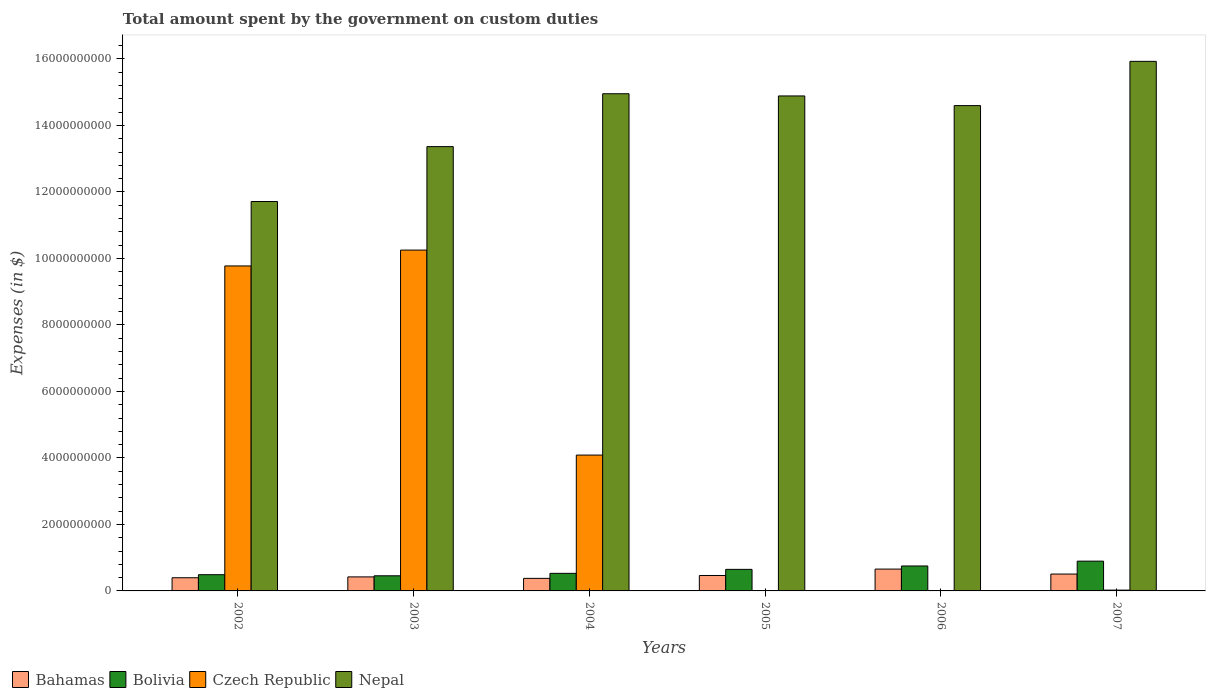How many different coloured bars are there?
Offer a terse response. 4. How many groups of bars are there?
Offer a very short reply. 6. Are the number of bars on each tick of the X-axis equal?
Make the answer very short. No. How many bars are there on the 5th tick from the left?
Give a very brief answer. 4. How many bars are there on the 5th tick from the right?
Give a very brief answer. 4. What is the label of the 5th group of bars from the left?
Make the answer very short. 2006. In how many cases, is the number of bars for a given year not equal to the number of legend labels?
Keep it short and to the point. 1. What is the amount spent on custom duties by the government in Czech Republic in 2007?
Offer a very short reply. 2.40e+07. Across all years, what is the maximum amount spent on custom duties by the government in Czech Republic?
Ensure brevity in your answer.  1.03e+1. Across all years, what is the minimum amount spent on custom duties by the government in Bolivia?
Provide a succinct answer. 4.55e+08. What is the total amount spent on custom duties by the government in Bahamas in the graph?
Provide a short and direct response. 2.82e+09. What is the difference between the amount spent on custom duties by the government in Bolivia in 2006 and that in 2007?
Keep it short and to the point. -1.45e+08. What is the difference between the amount spent on custom duties by the government in Bolivia in 2007 and the amount spent on custom duties by the government in Czech Republic in 2005?
Provide a short and direct response. 8.96e+08. What is the average amount spent on custom duties by the government in Bahamas per year?
Make the answer very short. 4.71e+08. In the year 2006, what is the difference between the amount spent on custom duties by the government in Nepal and amount spent on custom duties by the government in Bolivia?
Offer a very short reply. 1.38e+1. What is the ratio of the amount spent on custom duties by the government in Bahamas in 2004 to that in 2006?
Offer a terse response. 0.57. Is the amount spent on custom duties by the government in Bahamas in 2003 less than that in 2007?
Keep it short and to the point. Yes. Is the difference between the amount spent on custom duties by the government in Nepal in 2002 and 2003 greater than the difference between the amount spent on custom duties by the government in Bolivia in 2002 and 2003?
Your response must be concise. No. What is the difference between the highest and the second highest amount spent on custom duties by the government in Nepal?
Your answer should be very brief. 9.74e+08. What is the difference between the highest and the lowest amount spent on custom duties by the government in Bahamas?
Give a very brief answer. 2.79e+08. Is the sum of the amount spent on custom duties by the government in Nepal in 2006 and 2007 greater than the maximum amount spent on custom duties by the government in Bahamas across all years?
Provide a short and direct response. Yes. Is it the case that in every year, the sum of the amount spent on custom duties by the government in Bolivia and amount spent on custom duties by the government in Nepal is greater than the sum of amount spent on custom duties by the government in Czech Republic and amount spent on custom duties by the government in Bahamas?
Offer a terse response. Yes. How many years are there in the graph?
Provide a short and direct response. 6. What is the difference between two consecutive major ticks on the Y-axis?
Make the answer very short. 2.00e+09. Are the values on the major ticks of Y-axis written in scientific E-notation?
Keep it short and to the point. No. What is the title of the graph?
Your answer should be compact. Total amount spent by the government on custom duties. What is the label or title of the X-axis?
Offer a very short reply. Years. What is the label or title of the Y-axis?
Your answer should be very brief. Expenses (in $). What is the Expenses (in $) in Bahamas in 2002?
Make the answer very short. 3.96e+08. What is the Expenses (in $) in Bolivia in 2002?
Offer a very short reply. 4.88e+08. What is the Expenses (in $) of Czech Republic in 2002?
Offer a very short reply. 9.78e+09. What is the Expenses (in $) of Nepal in 2002?
Keep it short and to the point. 1.17e+1. What is the Expenses (in $) in Bahamas in 2003?
Give a very brief answer. 4.22e+08. What is the Expenses (in $) of Bolivia in 2003?
Your answer should be very brief. 4.55e+08. What is the Expenses (in $) in Czech Republic in 2003?
Make the answer very short. 1.03e+1. What is the Expenses (in $) of Nepal in 2003?
Give a very brief answer. 1.34e+1. What is the Expenses (in $) in Bahamas in 2004?
Provide a succinct answer. 3.77e+08. What is the Expenses (in $) of Bolivia in 2004?
Give a very brief answer. 5.28e+08. What is the Expenses (in $) of Czech Republic in 2004?
Your response must be concise. 4.09e+09. What is the Expenses (in $) in Nepal in 2004?
Offer a terse response. 1.50e+1. What is the Expenses (in $) in Bahamas in 2005?
Make the answer very short. 4.64e+08. What is the Expenses (in $) of Bolivia in 2005?
Give a very brief answer. 6.48e+08. What is the Expenses (in $) in Nepal in 2005?
Provide a short and direct response. 1.49e+1. What is the Expenses (in $) of Bahamas in 2006?
Provide a succinct answer. 6.57e+08. What is the Expenses (in $) of Bolivia in 2006?
Give a very brief answer. 7.50e+08. What is the Expenses (in $) in Czech Republic in 2006?
Keep it short and to the point. 6.00e+06. What is the Expenses (in $) in Nepal in 2006?
Your answer should be very brief. 1.46e+1. What is the Expenses (in $) in Bahamas in 2007?
Provide a succinct answer. 5.07e+08. What is the Expenses (in $) in Bolivia in 2007?
Provide a succinct answer. 8.96e+08. What is the Expenses (in $) of Czech Republic in 2007?
Keep it short and to the point. 2.40e+07. What is the Expenses (in $) in Nepal in 2007?
Provide a succinct answer. 1.59e+1. Across all years, what is the maximum Expenses (in $) of Bahamas?
Provide a short and direct response. 6.57e+08. Across all years, what is the maximum Expenses (in $) of Bolivia?
Offer a terse response. 8.96e+08. Across all years, what is the maximum Expenses (in $) of Czech Republic?
Your answer should be very brief. 1.03e+1. Across all years, what is the maximum Expenses (in $) in Nepal?
Make the answer very short. 1.59e+1. Across all years, what is the minimum Expenses (in $) in Bahamas?
Your response must be concise. 3.77e+08. Across all years, what is the minimum Expenses (in $) in Bolivia?
Keep it short and to the point. 4.55e+08. Across all years, what is the minimum Expenses (in $) of Nepal?
Make the answer very short. 1.17e+1. What is the total Expenses (in $) of Bahamas in the graph?
Offer a terse response. 2.82e+09. What is the total Expenses (in $) of Bolivia in the graph?
Offer a terse response. 3.77e+09. What is the total Expenses (in $) of Czech Republic in the graph?
Make the answer very short. 2.41e+1. What is the total Expenses (in $) in Nepal in the graph?
Your response must be concise. 8.54e+1. What is the difference between the Expenses (in $) in Bahamas in 2002 and that in 2003?
Give a very brief answer. -2.56e+07. What is the difference between the Expenses (in $) of Bolivia in 2002 and that in 2003?
Offer a very short reply. 3.30e+07. What is the difference between the Expenses (in $) of Czech Republic in 2002 and that in 2003?
Offer a very short reply. -4.77e+08. What is the difference between the Expenses (in $) in Nepal in 2002 and that in 2003?
Your answer should be compact. -1.65e+09. What is the difference between the Expenses (in $) of Bahamas in 2002 and that in 2004?
Ensure brevity in your answer.  1.87e+07. What is the difference between the Expenses (in $) in Bolivia in 2002 and that in 2004?
Ensure brevity in your answer.  -4.01e+07. What is the difference between the Expenses (in $) in Czech Republic in 2002 and that in 2004?
Offer a very short reply. 5.69e+09. What is the difference between the Expenses (in $) in Nepal in 2002 and that in 2004?
Offer a very short reply. -3.24e+09. What is the difference between the Expenses (in $) of Bahamas in 2002 and that in 2005?
Provide a short and direct response. -6.81e+07. What is the difference between the Expenses (in $) of Bolivia in 2002 and that in 2005?
Your response must be concise. -1.60e+08. What is the difference between the Expenses (in $) of Nepal in 2002 and that in 2005?
Offer a very short reply. -3.18e+09. What is the difference between the Expenses (in $) of Bahamas in 2002 and that in 2006?
Make the answer very short. -2.60e+08. What is the difference between the Expenses (in $) in Bolivia in 2002 and that in 2006?
Offer a very short reply. -2.62e+08. What is the difference between the Expenses (in $) in Czech Republic in 2002 and that in 2006?
Ensure brevity in your answer.  9.77e+09. What is the difference between the Expenses (in $) of Nepal in 2002 and that in 2006?
Your answer should be very brief. -2.88e+09. What is the difference between the Expenses (in $) in Bahamas in 2002 and that in 2007?
Ensure brevity in your answer.  -1.11e+08. What is the difference between the Expenses (in $) in Bolivia in 2002 and that in 2007?
Your answer should be compact. -4.07e+08. What is the difference between the Expenses (in $) of Czech Republic in 2002 and that in 2007?
Make the answer very short. 9.75e+09. What is the difference between the Expenses (in $) in Nepal in 2002 and that in 2007?
Offer a very short reply. -4.22e+09. What is the difference between the Expenses (in $) of Bahamas in 2003 and that in 2004?
Your response must be concise. 4.43e+07. What is the difference between the Expenses (in $) of Bolivia in 2003 and that in 2004?
Provide a succinct answer. -7.31e+07. What is the difference between the Expenses (in $) of Czech Republic in 2003 and that in 2004?
Provide a short and direct response. 6.17e+09. What is the difference between the Expenses (in $) of Nepal in 2003 and that in 2004?
Offer a terse response. -1.59e+09. What is the difference between the Expenses (in $) in Bahamas in 2003 and that in 2005?
Make the answer very short. -4.25e+07. What is the difference between the Expenses (in $) in Bolivia in 2003 and that in 2005?
Offer a terse response. -1.93e+08. What is the difference between the Expenses (in $) of Nepal in 2003 and that in 2005?
Keep it short and to the point. -1.52e+09. What is the difference between the Expenses (in $) in Bahamas in 2003 and that in 2006?
Your answer should be compact. -2.35e+08. What is the difference between the Expenses (in $) of Bolivia in 2003 and that in 2006?
Offer a very short reply. -2.95e+08. What is the difference between the Expenses (in $) in Czech Republic in 2003 and that in 2006?
Your answer should be compact. 1.02e+1. What is the difference between the Expenses (in $) of Nepal in 2003 and that in 2006?
Your answer should be very brief. -1.23e+09. What is the difference between the Expenses (in $) of Bahamas in 2003 and that in 2007?
Keep it short and to the point. -8.56e+07. What is the difference between the Expenses (in $) in Bolivia in 2003 and that in 2007?
Your answer should be compact. -4.40e+08. What is the difference between the Expenses (in $) in Czech Republic in 2003 and that in 2007?
Keep it short and to the point. 1.02e+1. What is the difference between the Expenses (in $) of Nepal in 2003 and that in 2007?
Offer a very short reply. -2.56e+09. What is the difference between the Expenses (in $) in Bahamas in 2004 and that in 2005?
Offer a terse response. -8.68e+07. What is the difference between the Expenses (in $) in Bolivia in 2004 and that in 2005?
Offer a very short reply. -1.20e+08. What is the difference between the Expenses (in $) of Nepal in 2004 and that in 2005?
Ensure brevity in your answer.  6.61e+07. What is the difference between the Expenses (in $) in Bahamas in 2004 and that in 2006?
Offer a very short reply. -2.79e+08. What is the difference between the Expenses (in $) of Bolivia in 2004 and that in 2006?
Provide a short and direct response. -2.22e+08. What is the difference between the Expenses (in $) in Czech Republic in 2004 and that in 2006?
Ensure brevity in your answer.  4.08e+09. What is the difference between the Expenses (in $) in Nepal in 2004 and that in 2006?
Provide a short and direct response. 3.57e+08. What is the difference between the Expenses (in $) of Bahamas in 2004 and that in 2007?
Your answer should be very brief. -1.30e+08. What is the difference between the Expenses (in $) in Bolivia in 2004 and that in 2007?
Ensure brevity in your answer.  -3.67e+08. What is the difference between the Expenses (in $) of Czech Republic in 2004 and that in 2007?
Make the answer very short. 4.06e+09. What is the difference between the Expenses (in $) in Nepal in 2004 and that in 2007?
Make the answer very short. -9.74e+08. What is the difference between the Expenses (in $) of Bahamas in 2005 and that in 2006?
Your response must be concise. -1.92e+08. What is the difference between the Expenses (in $) of Bolivia in 2005 and that in 2006?
Ensure brevity in your answer.  -1.02e+08. What is the difference between the Expenses (in $) in Nepal in 2005 and that in 2006?
Your response must be concise. 2.91e+08. What is the difference between the Expenses (in $) in Bahamas in 2005 and that in 2007?
Your answer should be compact. -4.31e+07. What is the difference between the Expenses (in $) in Bolivia in 2005 and that in 2007?
Your response must be concise. -2.47e+08. What is the difference between the Expenses (in $) of Nepal in 2005 and that in 2007?
Provide a short and direct response. -1.04e+09. What is the difference between the Expenses (in $) in Bahamas in 2006 and that in 2007?
Provide a short and direct response. 1.49e+08. What is the difference between the Expenses (in $) of Bolivia in 2006 and that in 2007?
Make the answer very short. -1.45e+08. What is the difference between the Expenses (in $) of Czech Republic in 2006 and that in 2007?
Your response must be concise. -1.80e+07. What is the difference between the Expenses (in $) of Nepal in 2006 and that in 2007?
Provide a succinct answer. -1.33e+09. What is the difference between the Expenses (in $) in Bahamas in 2002 and the Expenses (in $) in Bolivia in 2003?
Offer a terse response. -5.90e+07. What is the difference between the Expenses (in $) in Bahamas in 2002 and the Expenses (in $) in Czech Republic in 2003?
Offer a very short reply. -9.86e+09. What is the difference between the Expenses (in $) of Bahamas in 2002 and the Expenses (in $) of Nepal in 2003?
Make the answer very short. -1.30e+1. What is the difference between the Expenses (in $) of Bolivia in 2002 and the Expenses (in $) of Czech Republic in 2003?
Your answer should be compact. -9.76e+09. What is the difference between the Expenses (in $) in Bolivia in 2002 and the Expenses (in $) in Nepal in 2003?
Make the answer very short. -1.29e+1. What is the difference between the Expenses (in $) in Czech Republic in 2002 and the Expenses (in $) in Nepal in 2003?
Give a very brief answer. -3.59e+09. What is the difference between the Expenses (in $) of Bahamas in 2002 and the Expenses (in $) of Bolivia in 2004?
Offer a very short reply. -1.32e+08. What is the difference between the Expenses (in $) in Bahamas in 2002 and the Expenses (in $) in Czech Republic in 2004?
Make the answer very short. -3.69e+09. What is the difference between the Expenses (in $) in Bahamas in 2002 and the Expenses (in $) in Nepal in 2004?
Keep it short and to the point. -1.46e+1. What is the difference between the Expenses (in $) of Bolivia in 2002 and the Expenses (in $) of Czech Republic in 2004?
Provide a short and direct response. -3.60e+09. What is the difference between the Expenses (in $) in Bolivia in 2002 and the Expenses (in $) in Nepal in 2004?
Offer a very short reply. -1.45e+1. What is the difference between the Expenses (in $) of Czech Republic in 2002 and the Expenses (in $) of Nepal in 2004?
Keep it short and to the point. -5.18e+09. What is the difference between the Expenses (in $) in Bahamas in 2002 and the Expenses (in $) in Bolivia in 2005?
Ensure brevity in your answer.  -2.52e+08. What is the difference between the Expenses (in $) in Bahamas in 2002 and the Expenses (in $) in Nepal in 2005?
Give a very brief answer. -1.45e+1. What is the difference between the Expenses (in $) in Bolivia in 2002 and the Expenses (in $) in Nepal in 2005?
Provide a short and direct response. -1.44e+1. What is the difference between the Expenses (in $) of Czech Republic in 2002 and the Expenses (in $) of Nepal in 2005?
Ensure brevity in your answer.  -5.11e+09. What is the difference between the Expenses (in $) of Bahamas in 2002 and the Expenses (in $) of Bolivia in 2006?
Provide a short and direct response. -3.54e+08. What is the difference between the Expenses (in $) in Bahamas in 2002 and the Expenses (in $) in Czech Republic in 2006?
Provide a succinct answer. 3.90e+08. What is the difference between the Expenses (in $) of Bahamas in 2002 and the Expenses (in $) of Nepal in 2006?
Give a very brief answer. -1.42e+1. What is the difference between the Expenses (in $) of Bolivia in 2002 and the Expenses (in $) of Czech Republic in 2006?
Give a very brief answer. 4.82e+08. What is the difference between the Expenses (in $) in Bolivia in 2002 and the Expenses (in $) in Nepal in 2006?
Offer a terse response. -1.41e+1. What is the difference between the Expenses (in $) of Czech Republic in 2002 and the Expenses (in $) of Nepal in 2006?
Your response must be concise. -4.82e+09. What is the difference between the Expenses (in $) in Bahamas in 2002 and the Expenses (in $) in Bolivia in 2007?
Ensure brevity in your answer.  -4.99e+08. What is the difference between the Expenses (in $) in Bahamas in 2002 and the Expenses (in $) in Czech Republic in 2007?
Give a very brief answer. 3.72e+08. What is the difference between the Expenses (in $) of Bahamas in 2002 and the Expenses (in $) of Nepal in 2007?
Keep it short and to the point. -1.55e+1. What is the difference between the Expenses (in $) in Bolivia in 2002 and the Expenses (in $) in Czech Republic in 2007?
Make the answer very short. 4.64e+08. What is the difference between the Expenses (in $) in Bolivia in 2002 and the Expenses (in $) in Nepal in 2007?
Ensure brevity in your answer.  -1.54e+1. What is the difference between the Expenses (in $) in Czech Republic in 2002 and the Expenses (in $) in Nepal in 2007?
Your response must be concise. -6.15e+09. What is the difference between the Expenses (in $) in Bahamas in 2003 and the Expenses (in $) in Bolivia in 2004?
Your answer should be compact. -1.06e+08. What is the difference between the Expenses (in $) in Bahamas in 2003 and the Expenses (in $) in Czech Republic in 2004?
Your response must be concise. -3.66e+09. What is the difference between the Expenses (in $) in Bahamas in 2003 and the Expenses (in $) in Nepal in 2004?
Offer a terse response. -1.45e+1. What is the difference between the Expenses (in $) in Bolivia in 2003 and the Expenses (in $) in Czech Republic in 2004?
Offer a very short reply. -3.63e+09. What is the difference between the Expenses (in $) in Bolivia in 2003 and the Expenses (in $) in Nepal in 2004?
Provide a short and direct response. -1.45e+1. What is the difference between the Expenses (in $) in Czech Republic in 2003 and the Expenses (in $) in Nepal in 2004?
Your response must be concise. -4.70e+09. What is the difference between the Expenses (in $) in Bahamas in 2003 and the Expenses (in $) in Bolivia in 2005?
Your response must be concise. -2.27e+08. What is the difference between the Expenses (in $) of Bahamas in 2003 and the Expenses (in $) of Nepal in 2005?
Provide a short and direct response. -1.45e+1. What is the difference between the Expenses (in $) of Bolivia in 2003 and the Expenses (in $) of Nepal in 2005?
Your response must be concise. -1.44e+1. What is the difference between the Expenses (in $) in Czech Republic in 2003 and the Expenses (in $) in Nepal in 2005?
Your answer should be very brief. -4.64e+09. What is the difference between the Expenses (in $) of Bahamas in 2003 and the Expenses (in $) of Bolivia in 2006?
Offer a terse response. -3.29e+08. What is the difference between the Expenses (in $) of Bahamas in 2003 and the Expenses (in $) of Czech Republic in 2006?
Your answer should be very brief. 4.16e+08. What is the difference between the Expenses (in $) of Bahamas in 2003 and the Expenses (in $) of Nepal in 2006?
Provide a succinct answer. -1.42e+1. What is the difference between the Expenses (in $) of Bolivia in 2003 and the Expenses (in $) of Czech Republic in 2006?
Give a very brief answer. 4.49e+08. What is the difference between the Expenses (in $) of Bolivia in 2003 and the Expenses (in $) of Nepal in 2006?
Your answer should be compact. -1.41e+1. What is the difference between the Expenses (in $) of Czech Republic in 2003 and the Expenses (in $) of Nepal in 2006?
Keep it short and to the point. -4.35e+09. What is the difference between the Expenses (in $) of Bahamas in 2003 and the Expenses (in $) of Bolivia in 2007?
Your answer should be compact. -4.74e+08. What is the difference between the Expenses (in $) in Bahamas in 2003 and the Expenses (in $) in Czech Republic in 2007?
Give a very brief answer. 3.98e+08. What is the difference between the Expenses (in $) in Bahamas in 2003 and the Expenses (in $) in Nepal in 2007?
Offer a very short reply. -1.55e+1. What is the difference between the Expenses (in $) of Bolivia in 2003 and the Expenses (in $) of Czech Republic in 2007?
Ensure brevity in your answer.  4.31e+08. What is the difference between the Expenses (in $) of Bolivia in 2003 and the Expenses (in $) of Nepal in 2007?
Provide a short and direct response. -1.55e+1. What is the difference between the Expenses (in $) of Czech Republic in 2003 and the Expenses (in $) of Nepal in 2007?
Provide a short and direct response. -5.68e+09. What is the difference between the Expenses (in $) in Bahamas in 2004 and the Expenses (in $) in Bolivia in 2005?
Provide a succinct answer. -2.71e+08. What is the difference between the Expenses (in $) of Bahamas in 2004 and the Expenses (in $) of Nepal in 2005?
Offer a very short reply. -1.45e+1. What is the difference between the Expenses (in $) of Bolivia in 2004 and the Expenses (in $) of Nepal in 2005?
Your answer should be very brief. -1.44e+1. What is the difference between the Expenses (in $) in Czech Republic in 2004 and the Expenses (in $) in Nepal in 2005?
Your response must be concise. -1.08e+1. What is the difference between the Expenses (in $) in Bahamas in 2004 and the Expenses (in $) in Bolivia in 2006?
Your answer should be very brief. -3.73e+08. What is the difference between the Expenses (in $) in Bahamas in 2004 and the Expenses (in $) in Czech Republic in 2006?
Offer a very short reply. 3.71e+08. What is the difference between the Expenses (in $) in Bahamas in 2004 and the Expenses (in $) in Nepal in 2006?
Offer a terse response. -1.42e+1. What is the difference between the Expenses (in $) in Bolivia in 2004 and the Expenses (in $) in Czech Republic in 2006?
Ensure brevity in your answer.  5.22e+08. What is the difference between the Expenses (in $) of Bolivia in 2004 and the Expenses (in $) of Nepal in 2006?
Your answer should be compact. -1.41e+1. What is the difference between the Expenses (in $) of Czech Republic in 2004 and the Expenses (in $) of Nepal in 2006?
Your response must be concise. -1.05e+1. What is the difference between the Expenses (in $) in Bahamas in 2004 and the Expenses (in $) in Bolivia in 2007?
Your answer should be compact. -5.18e+08. What is the difference between the Expenses (in $) in Bahamas in 2004 and the Expenses (in $) in Czech Republic in 2007?
Your answer should be very brief. 3.53e+08. What is the difference between the Expenses (in $) in Bahamas in 2004 and the Expenses (in $) in Nepal in 2007?
Ensure brevity in your answer.  -1.56e+1. What is the difference between the Expenses (in $) of Bolivia in 2004 and the Expenses (in $) of Czech Republic in 2007?
Your response must be concise. 5.04e+08. What is the difference between the Expenses (in $) in Bolivia in 2004 and the Expenses (in $) in Nepal in 2007?
Give a very brief answer. -1.54e+1. What is the difference between the Expenses (in $) in Czech Republic in 2004 and the Expenses (in $) in Nepal in 2007?
Keep it short and to the point. -1.18e+1. What is the difference between the Expenses (in $) in Bahamas in 2005 and the Expenses (in $) in Bolivia in 2006?
Offer a very short reply. -2.86e+08. What is the difference between the Expenses (in $) of Bahamas in 2005 and the Expenses (in $) of Czech Republic in 2006?
Give a very brief answer. 4.58e+08. What is the difference between the Expenses (in $) of Bahamas in 2005 and the Expenses (in $) of Nepal in 2006?
Provide a succinct answer. -1.41e+1. What is the difference between the Expenses (in $) in Bolivia in 2005 and the Expenses (in $) in Czech Republic in 2006?
Offer a very short reply. 6.42e+08. What is the difference between the Expenses (in $) in Bolivia in 2005 and the Expenses (in $) in Nepal in 2006?
Offer a terse response. -1.39e+1. What is the difference between the Expenses (in $) in Bahamas in 2005 and the Expenses (in $) in Bolivia in 2007?
Offer a terse response. -4.31e+08. What is the difference between the Expenses (in $) in Bahamas in 2005 and the Expenses (in $) in Czech Republic in 2007?
Offer a terse response. 4.40e+08. What is the difference between the Expenses (in $) in Bahamas in 2005 and the Expenses (in $) in Nepal in 2007?
Ensure brevity in your answer.  -1.55e+1. What is the difference between the Expenses (in $) in Bolivia in 2005 and the Expenses (in $) in Czech Republic in 2007?
Offer a very short reply. 6.24e+08. What is the difference between the Expenses (in $) in Bolivia in 2005 and the Expenses (in $) in Nepal in 2007?
Your answer should be very brief. -1.53e+1. What is the difference between the Expenses (in $) in Bahamas in 2006 and the Expenses (in $) in Bolivia in 2007?
Provide a succinct answer. -2.39e+08. What is the difference between the Expenses (in $) in Bahamas in 2006 and the Expenses (in $) in Czech Republic in 2007?
Your answer should be very brief. 6.33e+08. What is the difference between the Expenses (in $) in Bahamas in 2006 and the Expenses (in $) in Nepal in 2007?
Provide a short and direct response. -1.53e+1. What is the difference between the Expenses (in $) in Bolivia in 2006 and the Expenses (in $) in Czech Republic in 2007?
Keep it short and to the point. 7.26e+08. What is the difference between the Expenses (in $) in Bolivia in 2006 and the Expenses (in $) in Nepal in 2007?
Keep it short and to the point. -1.52e+1. What is the difference between the Expenses (in $) of Czech Republic in 2006 and the Expenses (in $) of Nepal in 2007?
Offer a terse response. -1.59e+1. What is the average Expenses (in $) in Bahamas per year?
Offer a very short reply. 4.71e+08. What is the average Expenses (in $) in Bolivia per year?
Your answer should be very brief. 6.28e+08. What is the average Expenses (in $) of Czech Republic per year?
Your answer should be very brief. 4.02e+09. What is the average Expenses (in $) in Nepal per year?
Give a very brief answer. 1.42e+1. In the year 2002, what is the difference between the Expenses (in $) in Bahamas and Expenses (in $) in Bolivia?
Ensure brevity in your answer.  -9.20e+07. In the year 2002, what is the difference between the Expenses (in $) in Bahamas and Expenses (in $) in Czech Republic?
Your response must be concise. -9.38e+09. In the year 2002, what is the difference between the Expenses (in $) in Bahamas and Expenses (in $) in Nepal?
Offer a terse response. -1.13e+1. In the year 2002, what is the difference between the Expenses (in $) in Bolivia and Expenses (in $) in Czech Republic?
Keep it short and to the point. -9.29e+09. In the year 2002, what is the difference between the Expenses (in $) of Bolivia and Expenses (in $) of Nepal?
Provide a succinct answer. -1.12e+1. In the year 2002, what is the difference between the Expenses (in $) in Czech Republic and Expenses (in $) in Nepal?
Give a very brief answer. -1.94e+09. In the year 2003, what is the difference between the Expenses (in $) of Bahamas and Expenses (in $) of Bolivia?
Provide a short and direct response. -3.34e+07. In the year 2003, what is the difference between the Expenses (in $) in Bahamas and Expenses (in $) in Czech Republic?
Your response must be concise. -9.83e+09. In the year 2003, what is the difference between the Expenses (in $) in Bahamas and Expenses (in $) in Nepal?
Keep it short and to the point. -1.29e+1. In the year 2003, what is the difference between the Expenses (in $) in Bolivia and Expenses (in $) in Czech Republic?
Your answer should be compact. -9.80e+09. In the year 2003, what is the difference between the Expenses (in $) of Bolivia and Expenses (in $) of Nepal?
Give a very brief answer. -1.29e+1. In the year 2003, what is the difference between the Expenses (in $) in Czech Republic and Expenses (in $) in Nepal?
Ensure brevity in your answer.  -3.11e+09. In the year 2004, what is the difference between the Expenses (in $) of Bahamas and Expenses (in $) of Bolivia?
Offer a terse response. -1.51e+08. In the year 2004, what is the difference between the Expenses (in $) of Bahamas and Expenses (in $) of Czech Republic?
Ensure brevity in your answer.  -3.71e+09. In the year 2004, what is the difference between the Expenses (in $) in Bahamas and Expenses (in $) in Nepal?
Offer a terse response. -1.46e+1. In the year 2004, what is the difference between the Expenses (in $) of Bolivia and Expenses (in $) of Czech Republic?
Give a very brief answer. -3.56e+09. In the year 2004, what is the difference between the Expenses (in $) in Bolivia and Expenses (in $) in Nepal?
Provide a short and direct response. -1.44e+1. In the year 2004, what is the difference between the Expenses (in $) of Czech Republic and Expenses (in $) of Nepal?
Your answer should be compact. -1.09e+1. In the year 2005, what is the difference between the Expenses (in $) in Bahamas and Expenses (in $) in Bolivia?
Your response must be concise. -1.84e+08. In the year 2005, what is the difference between the Expenses (in $) in Bahamas and Expenses (in $) in Nepal?
Ensure brevity in your answer.  -1.44e+1. In the year 2005, what is the difference between the Expenses (in $) of Bolivia and Expenses (in $) of Nepal?
Give a very brief answer. -1.42e+1. In the year 2006, what is the difference between the Expenses (in $) in Bahamas and Expenses (in $) in Bolivia?
Give a very brief answer. -9.37e+07. In the year 2006, what is the difference between the Expenses (in $) of Bahamas and Expenses (in $) of Czech Republic?
Ensure brevity in your answer.  6.51e+08. In the year 2006, what is the difference between the Expenses (in $) in Bahamas and Expenses (in $) in Nepal?
Your answer should be very brief. -1.39e+1. In the year 2006, what is the difference between the Expenses (in $) in Bolivia and Expenses (in $) in Czech Republic?
Give a very brief answer. 7.44e+08. In the year 2006, what is the difference between the Expenses (in $) in Bolivia and Expenses (in $) in Nepal?
Offer a very short reply. -1.38e+1. In the year 2006, what is the difference between the Expenses (in $) in Czech Republic and Expenses (in $) in Nepal?
Your answer should be compact. -1.46e+1. In the year 2007, what is the difference between the Expenses (in $) in Bahamas and Expenses (in $) in Bolivia?
Keep it short and to the point. -3.88e+08. In the year 2007, what is the difference between the Expenses (in $) in Bahamas and Expenses (in $) in Czech Republic?
Your response must be concise. 4.83e+08. In the year 2007, what is the difference between the Expenses (in $) of Bahamas and Expenses (in $) of Nepal?
Give a very brief answer. -1.54e+1. In the year 2007, what is the difference between the Expenses (in $) in Bolivia and Expenses (in $) in Czech Republic?
Keep it short and to the point. 8.72e+08. In the year 2007, what is the difference between the Expenses (in $) in Bolivia and Expenses (in $) in Nepal?
Make the answer very short. -1.50e+1. In the year 2007, what is the difference between the Expenses (in $) in Czech Republic and Expenses (in $) in Nepal?
Provide a short and direct response. -1.59e+1. What is the ratio of the Expenses (in $) in Bahamas in 2002 to that in 2003?
Provide a succinct answer. 0.94. What is the ratio of the Expenses (in $) in Bolivia in 2002 to that in 2003?
Your answer should be very brief. 1.07. What is the ratio of the Expenses (in $) of Czech Republic in 2002 to that in 2003?
Give a very brief answer. 0.95. What is the ratio of the Expenses (in $) in Nepal in 2002 to that in 2003?
Provide a short and direct response. 0.88. What is the ratio of the Expenses (in $) of Bahamas in 2002 to that in 2004?
Give a very brief answer. 1.05. What is the ratio of the Expenses (in $) of Bolivia in 2002 to that in 2004?
Provide a short and direct response. 0.92. What is the ratio of the Expenses (in $) in Czech Republic in 2002 to that in 2004?
Offer a terse response. 2.39. What is the ratio of the Expenses (in $) in Nepal in 2002 to that in 2004?
Your answer should be very brief. 0.78. What is the ratio of the Expenses (in $) in Bahamas in 2002 to that in 2005?
Offer a very short reply. 0.85. What is the ratio of the Expenses (in $) of Bolivia in 2002 to that in 2005?
Provide a short and direct response. 0.75. What is the ratio of the Expenses (in $) in Nepal in 2002 to that in 2005?
Offer a very short reply. 0.79. What is the ratio of the Expenses (in $) in Bahamas in 2002 to that in 2006?
Your response must be concise. 0.6. What is the ratio of the Expenses (in $) in Bolivia in 2002 to that in 2006?
Give a very brief answer. 0.65. What is the ratio of the Expenses (in $) in Czech Republic in 2002 to that in 2006?
Provide a succinct answer. 1629.17. What is the ratio of the Expenses (in $) in Nepal in 2002 to that in 2006?
Provide a succinct answer. 0.8. What is the ratio of the Expenses (in $) of Bahamas in 2002 to that in 2007?
Provide a short and direct response. 0.78. What is the ratio of the Expenses (in $) in Bolivia in 2002 to that in 2007?
Make the answer very short. 0.55. What is the ratio of the Expenses (in $) in Czech Republic in 2002 to that in 2007?
Offer a very short reply. 407.29. What is the ratio of the Expenses (in $) of Nepal in 2002 to that in 2007?
Ensure brevity in your answer.  0.74. What is the ratio of the Expenses (in $) in Bahamas in 2003 to that in 2004?
Offer a very short reply. 1.12. What is the ratio of the Expenses (in $) of Bolivia in 2003 to that in 2004?
Offer a very short reply. 0.86. What is the ratio of the Expenses (in $) in Czech Republic in 2003 to that in 2004?
Offer a very short reply. 2.51. What is the ratio of the Expenses (in $) in Nepal in 2003 to that in 2004?
Provide a short and direct response. 0.89. What is the ratio of the Expenses (in $) in Bahamas in 2003 to that in 2005?
Make the answer very short. 0.91. What is the ratio of the Expenses (in $) of Bolivia in 2003 to that in 2005?
Offer a very short reply. 0.7. What is the ratio of the Expenses (in $) of Nepal in 2003 to that in 2005?
Your answer should be compact. 0.9. What is the ratio of the Expenses (in $) of Bahamas in 2003 to that in 2006?
Provide a succinct answer. 0.64. What is the ratio of the Expenses (in $) in Bolivia in 2003 to that in 2006?
Your answer should be very brief. 0.61. What is the ratio of the Expenses (in $) in Czech Republic in 2003 to that in 2006?
Offer a very short reply. 1708.67. What is the ratio of the Expenses (in $) of Nepal in 2003 to that in 2006?
Provide a succinct answer. 0.92. What is the ratio of the Expenses (in $) in Bahamas in 2003 to that in 2007?
Your response must be concise. 0.83. What is the ratio of the Expenses (in $) of Bolivia in 2003 to that in 2007?
Make the answer very short. 0.51. What is the ratio of the Expenses (in $) in Czech Republic in 2003 to that in 2007?
Offer a terse response. 427.17. What is the ratio of the Expenses (in $) of Nepal in 2003 to that in 2007?
Give a very brief answer. 0.84. What is the ratio of the Expenses (in $) of Bahamas in 2004 to that in 2005?
Your response must be concise. 0.81. What is the ratio of the Expenses (in $) in Bolivia in 2004 to that in 2005?
Your answer should be compact. 0.81. What is the ratio of the Expenses (in $) of Bahamas in 2004 to that in 2006?
Your response must be concise. 0.57. What is the ratio of the Expenses (in $) of Bolivia in 2004 to that in 2006?
Keep it short and to the point. 0.7. What is the ratio of the Expenses (in $) in Czech Republic in 2004 to that in 2006?
Keep it short and to the point. 681. What is the ratio of the Expenses (in $) in Nepal in 2004 to that in 2006?
Offer a very short reply. 1.02. What is the ratio of the Expenses (in $) in Bahamas in 2004 to that in 2007?
Give a very brief answer. 0.74. What is the ratio of the Expenses (in $) of Bolivia in 2004 to that in 2007?
Provide a succinct answer. 0.59. What is the ratio of the Expenses (in $) of Czech Republic in 2004 to that in 2007?
Make the answer very short. 170.25. What is the ratio of the Expenses (in $) in Nepal in 2004 to that in 2007?
Your response must be concise. 0.94. What is the ratio of the Expenses (in $) of Bahamas in 2005 to that in 2006?
Your response must be concise. 0.71. What is the ratio of the Expenses (in $) in Bolivia in 2005 to that in 2006?
Provide a succinct answer. 0.86. What is the ratio of the Expenses (in $) in Nepal in 2005 to that in 2006?
Keep it short and to the point. 1.02. What is the ratio of the Expenses (in $) of Bahamas in 2005 to that in 2007?
Your response must be concise. 0.92. What is the ratio of the Expenses (in $) of Bolivia in 2005 to that in 2007?
Keep it short and to the point. 0.72. What is the ratio of the Expenses (in $) of Nepal in 2005 to that in 2007?
Offer a terse response. 0.93. What is the ratio of the Expenses (in $) of Bahamas in 2006 to that in 2007?
Provide a succinct answer. 1.29. What is the ratio of the Expenses (in $) of Bolivia in 2006 to that in 2007?
Provide a short and direct response. 0.84. What is the ratio of the Expenses (in $) in Nepal in 2006 to that in 2007?
Offer a very short reply. 0.92. What is the difference between the highest and the second highest Expenses (in $) in Bahamas?
Offer a terse response. 1.49e+08. What is the difference between the highest and the second highest Expenses (in $) of Bolivia?
Ensure brevity in your answer.  1.45e+08. What is the difference between the highest and the second highest Expenses (in $) in Czech Republic?
Offer a very short reply. 4.77e+08. What is the difference between the highest and the second highest Expenses (in $) in Nepal?
Make the answer very short. 9.74e+08. What is the difference between the highest and the lowest Expenses (in $) in Bahamas?
Your response must be concise. 2.79e+08. What is the difference between the highest and the lowest Expenses (in $) of Bolivia?
Your answer should be compact. 4.40e+08. What is the difference between the highest and the lowest Expenses (in $) of Czech Republic?
Make the answer very short. 1.03e+1. What is the difference between the highest and the lowest Expenses (in $) in Nepal?
Ensure brevity in your answer.  4.22e+09. 